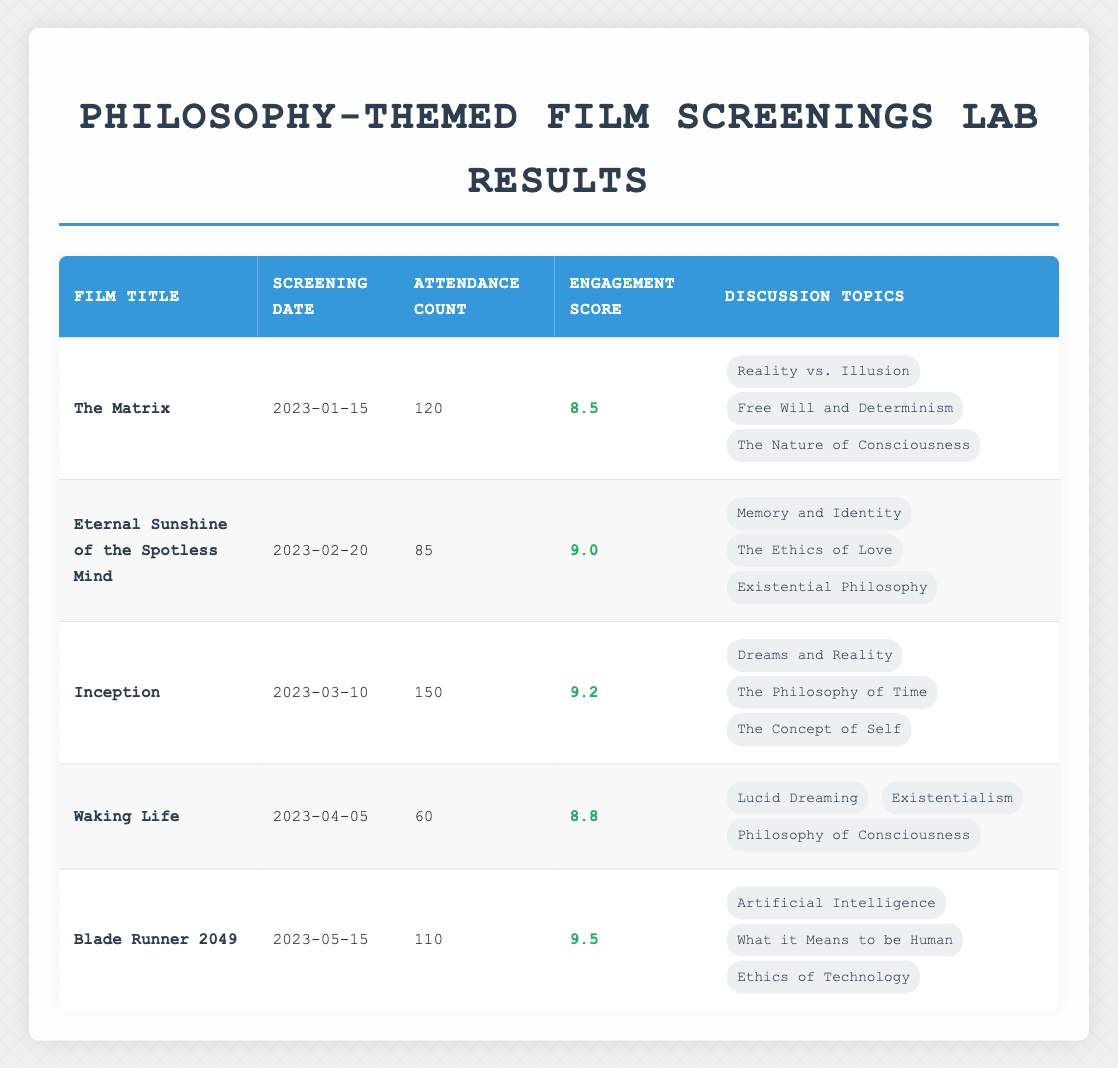What is the film with the highest engagement score? The highest engagement score is found in the row corresponding to "Blade Runner 2049," which has a score of 9.5. By looking down the Engagement Score column, we see that no other film exceeds this value.
Answer: Blade Runner 2049 How many people attended the screening of "Eternal Sunshine of the Spotless Mind"? The attendance count for "Eternal Sunshine of the Spotless Mind" is directly taken from the Attendance Count column, which lists the value as 85.
Answer: 85 What are the discussion topics for the film "Inception"? By referring to the row for "Inception," we can list the topics found in the Discussion Topics column, which are: "Dreams and Reality," "The Philosophy of Time," and "The Concept of Self."
Answer: Dreams and Reality, The Philosophy of Time, The Concept of Self What is the total attendance across all five film screenings? To find the total attendance, we will add up the attendance counts from each row: 120 (The Matrix) + 85 (Eternal Sunshine of the Spotless Mind) + 150 (Inception) + 60 (Waking Life) + 110 (Blade Runner 2049) = 525.
Answer: 525 Is there a film screening that focused on Existentialism? Looking through the discussion topics for each film, we find that "Waking Life" includes "Existentialism" as one of its topics, thus answering the question affirmatively.
Answer: Yes What is the average engagement score of all the films screened? First, we sum all the engagement scores: 8.5 (The Matrix) + 9.0 (Eternal Sunshine of the Spotless Mind) + 9.2 (Inception) + 8.8 (Waking Life) + 9.5 (Blade Runner 2049) = 44. The average engagement score is calculated by dividing this sum by the number of films, which is 44 / 5 = 8.8.
Answer: 8.8 Which film had the lowest attendance, and what was the attendance count? Scanning through the Attendance Count column, we find that "Waking Life" has the lowest attendance count of 60, making it the film with the least attendees.
Answer: Waking Life, 60 Did any film screenings have an engagement score of 9 or higher? Evaluating the Engagement Score column, we note that three films—"Eternal Sunshine of the Spotless Mind," "Inception," and "Blade Runner 2049"—all have scores of 9 or higher. Hence, the answer is affirmative.
Answer: Yes What are the screening dates of the two films with the highest attendance counts? By identifying the highest attendance counts (150 for Inception and 120 for The Matrix) from the Attendance Count column, we find their respective screening dates: "Inception" on 2023-03-10 and "The Matrix" on 2023-01-15.
Answer: 2023-03-10, 2023-01-15 